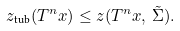<formula> <loc_0><loc_0><loc_500><loc_500>z _ { \text {tub} } ( T ^ { n } x ) \leq z ( T ^ { n } x , \, \tilde { \Sigma } ) .</formula> 